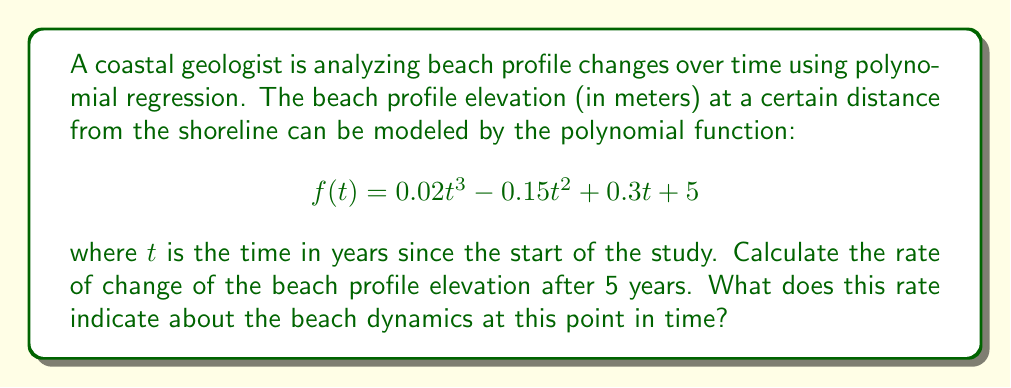What is the answer to this math problem? To solve this problem, we need to follow these steps:

1) The rate of change of the beach profile elevation is given by the first derivative of the function $f(t)$.

2) Let's find the derivative of $f(t)$:
   $$f'(t) = \frac{d}{dt}(0.02t^3 - 0.15t^2 + 0.3t + 5)$$
   $$f'(t) = 0.06t^2 - 0.3t + 0.3$$

3) Now, we need to evaluate $f'(t)$ at $t = 5$ years:
   $$f'(5) = 0.06(5)^2 - 0.3(5) + 0.3$$
   $$f'(5) = 0.06(25) - 1.5 + 0.3$$
   $$f'(5) = 1.5 - 1.5 + 0.3$$
   $$f'(5) = 0.3$$

4) Interpretation: The rate of change after 5 years is 0.3 meters per year. This positive value indicates that the beach elevation is increasing at this point in time.

In the context of coastal processes and sediment dynamics:
- A positive rate of change suggests accretion or beach growth.
- This could be due to sediment deposition, possibly from longshore drift or offshore sediment transport.
- The moderate rate (0.3 m/year) might indicate a relatively stable beach environment with gradual growth.
Answer: The rate of change of the beach profile elevation after 5 years is 0.3 meters per year, indicating beach accretion or growth at this point in time. 